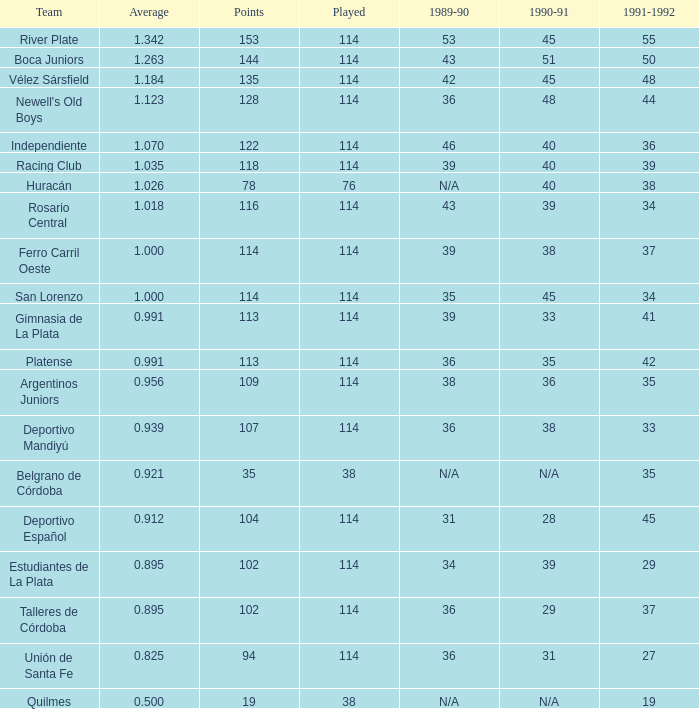8250000000000001? 0.0. 